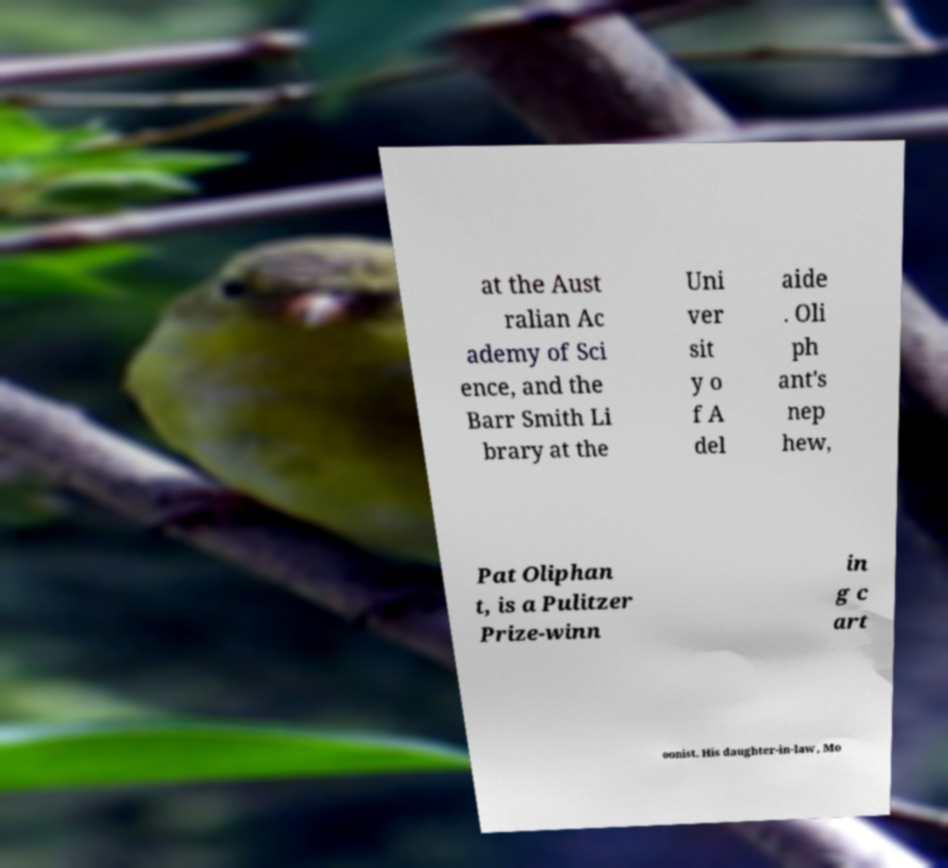For documentation purposes, I need the text within this image transcribed. Could you provide that? at the Aust ralian Ac ademy of Sci ence, and the Barr Smith Li brary at the Uni ver sit y o f A del aide . Oli ph ant's nep hew, Pat Oliphan t, is a Pulitzer Prize-winn in g c art oonist. His daughter-in-law, Mo 